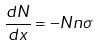<formula> <loc_0><loc_0><loc_500><loc_500>\frac { d N } { d x } = - N n \sigma</formula> 